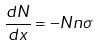<formula> <loc_0><loc_0><loc_500><loc_500>\frac { d N } { d x } = - N n \sigma</formula> 